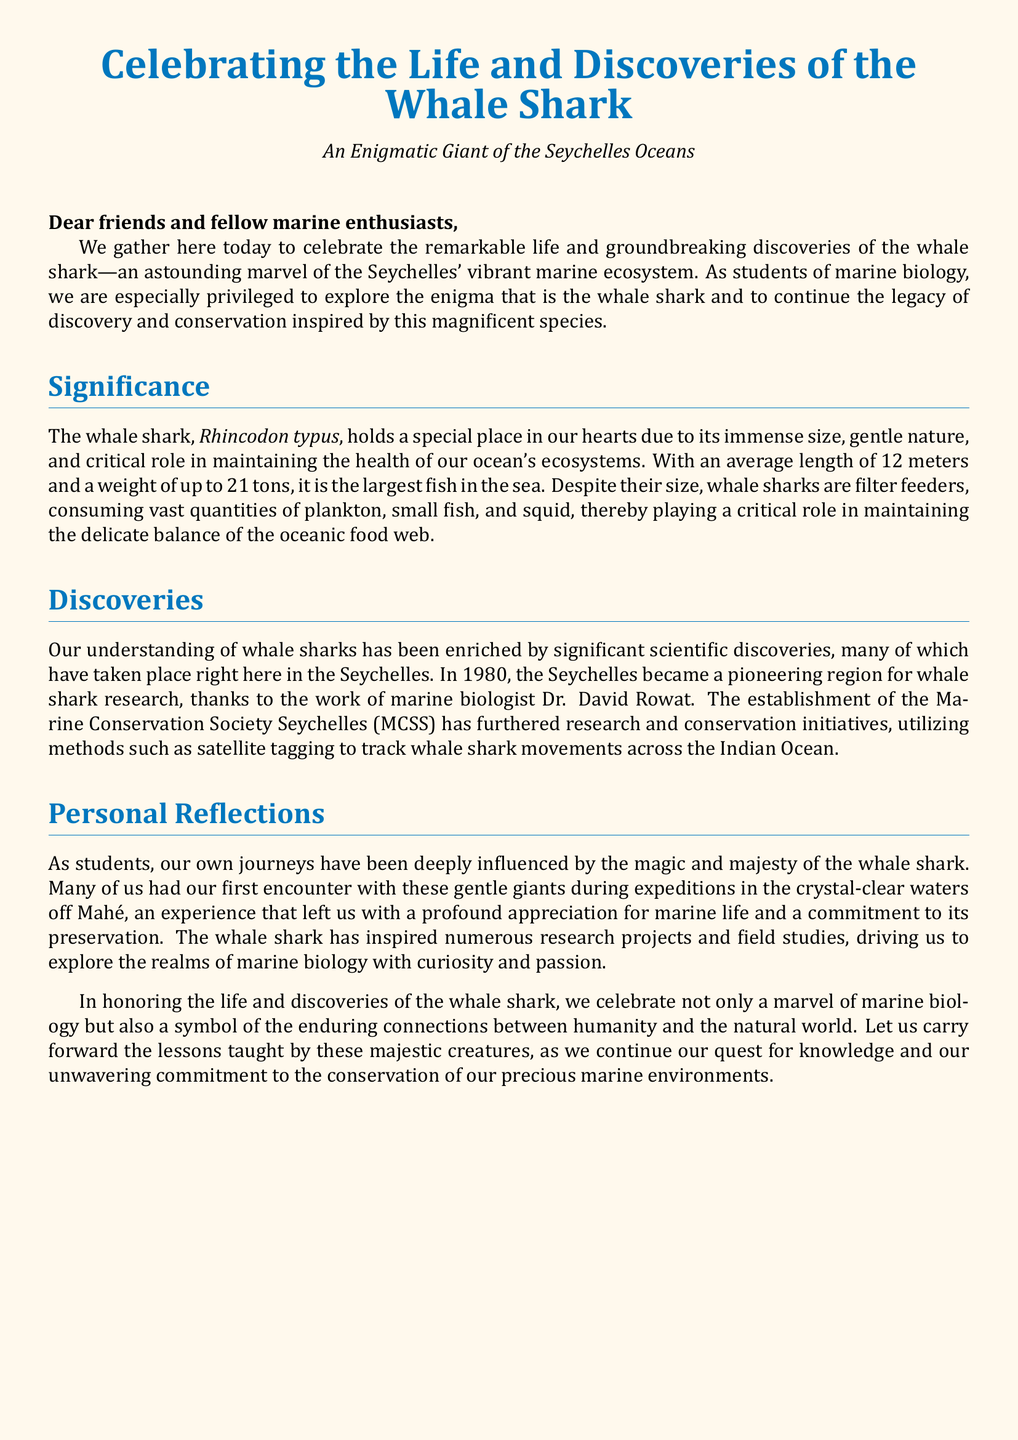What is the scientific name of the whale shark? The scientific name mentioned in the document is \textit{Rhincodon typus}.
Answer: \textit{Rhincodon typus} What year did the Seychelles become a pioneering region for whale shark research? The document states that in 1980, the Seychelles became a pioneering region for whale shark research.
Answer: 1980 Who is the marine biologist associated with early whale shark research in Seychelles? The document attributes the pioneering research work to marine biologist Dr. David Rowat.
Answer: Dr. David Rowat What is the average length of a whale shark? The document indicates that the average length of a whale shark is 12 meters.
Answer: 12 meters What is the primary diet of whale sharks? According to the document, whale sharks are filter feeders that consume vast quantities of plankton, small fish, and squid.
Answer: Plankton, small fish, and squid How does the document describe the whale shark's nature? The document describes whale sharks as having a gentle nature.
Answer: Gentle nature What role do whale sharks play in marine ecosystems? The document mentions that whale sharks play a critical role in maintaining the health of ocean ecosystems.
Answer: Maintaining the health of ocean ecosystems What organization has furthered research and conservation initiatives for whale sharks in Seychelles? The document references the Marine Conservation Society Seychelles (MCSS) as an organization that has furthered such initiatives.
Answer: Marine Conservation Society Seychelles (MCSS) What does the document urge students to carry forward in their quest for knowledge? The document encourages students to carry forward the lessons taught by these majestic creatures.
Answer: The lessons taught by these majestic creatures 